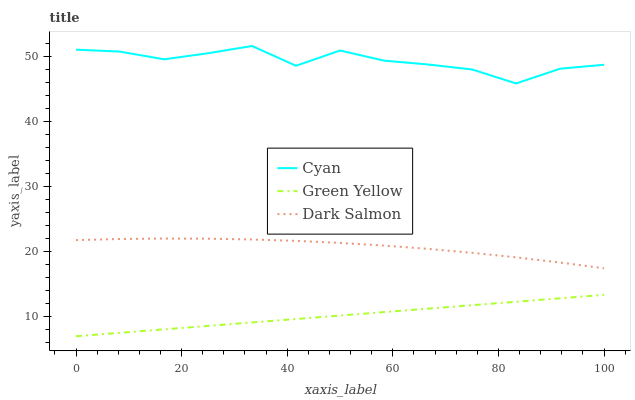Does Green Yellow have the minimum area under the curve?
Answer yes or no. Yes. Does Cyan have the maximum area under the curve?
Answer yes or no. Yes. Does Dark Salmon have the minimum area under the curve?
Answer yes or no. No. Does Dark Salmon have the maximum area under the curve?
Answer yes or no. No. Is Green Yellow the smoothest?
Answer yes or no. Yes. Is Cyan the roughest?
Answer yes or no. Yes. Is Dark Salmon the smoothest?
Answer yes or no. No. Is Dark Salmon the roughest?
Answer yes or no. No. Does Green Yellow have the lowest value?
Answer yes or no. Yes. Does Dark Salmon have the lowest value?
Answer yes or no. No. Does Cyan have the highest value?
Answer yes or no. Yes. Does Dark Salmon have the highest value?
Answer yes or no. No. Is Dark Salmon less than Cyan?
Answer yes or no. Yes. Is Dark Salmon greater than Green Yellow?
Answer yes or no. Yes. Does Dark Salmon intersect Cyan?
Answer yes or no. No. 